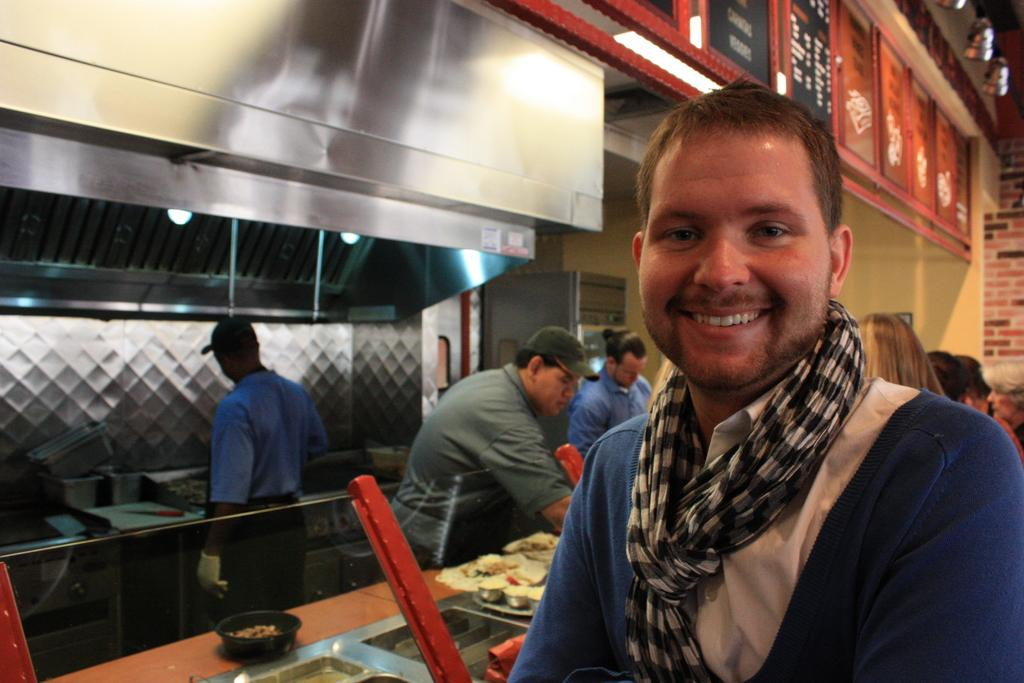What is the man in the image doing? The man is standing and smiling in the image. Where are the other people located in the image? The other people are standing on the left side of the image. What are the people on the left side doing? The people on the left side are cooking. What can be seen in the image that might be used for preparing or serving food? There are utensils visible in the image. What is placed on the table in the image? There is food placed on a table in the image. Can you tell me how many horses are present in the image? There are no horses present in the image. What type of soap is being used by the people in the image? There is no soap visible in the image, as it features people cooking and a man smiling. 